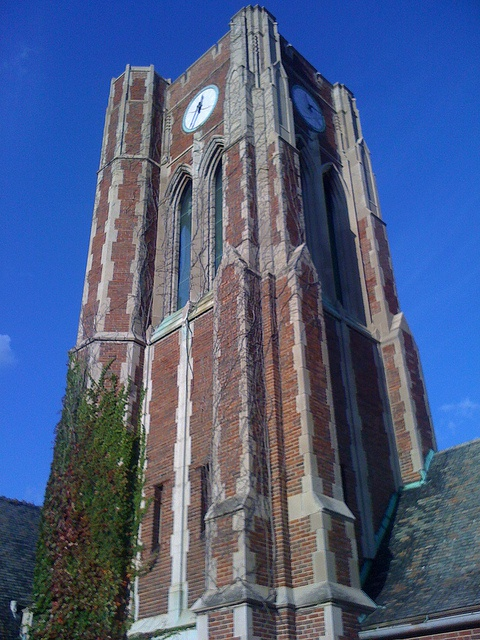Describe the objects in this image and their specific colors. I can see clock in blue, white, lightblue, and gray tones and clock in blue, navy, and darkblue tones in this image. 